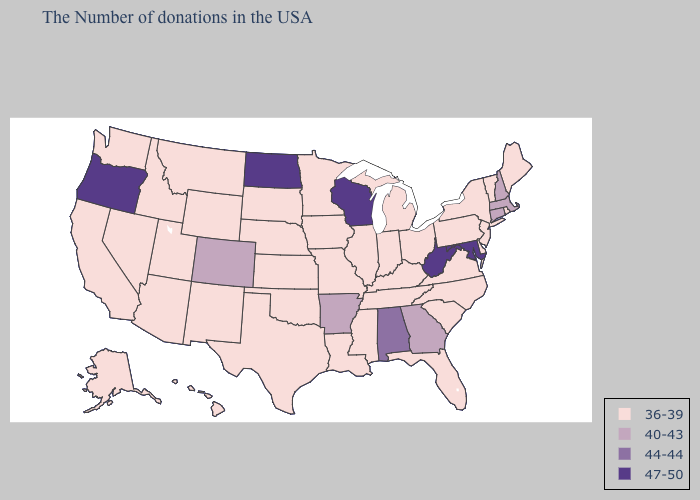Which states hav the highest value in the Northeast?
Write a very short answer. Massachusetts, New Hampshire, Connecticut. Does Kansas have the same value as Virginia?
Write a very short answer. Yes. Name the states that have a value in the range 47-50?
Quick response, please. Maryland, West Virginia, Wisconsin, North Dakota, Oregon. What is the value of New Jersey?
Short answer required. 36-39. Among the states that border Arkansas , which have the lowest value?
Be succinct. Tennessee, Mississippi, Louisiana, Missouri, Oklahoma, Texas. Does North Carolina have the highest value in the South?
Give a very brief answer. No. Name the states that have a value in the range 40-43?
Keep it brief. Massachusetts, New Hampshire, Connecticut, Georgia, Arkansas, Colorado. Does the first symbol in the legend represent the smallest category?
Be succinct. Yes. Name the states that have a value in the range 44-44?
Keep it brief. Alabama. Does Indiana have the lowest value in the USA?
Quick response, please. Yes. Does Indiana have the lowest value in the USA?
Short answer required. Yes. Name the states that have a value in the range 36-39?
Short answer required. Maine, Rhode Island, Vermont, New York, New Jersey, Delaware, Pennsylvania, Virginia, North Carolina, South Carolina, Ohio, Florida, Michigan, Kentucky, Indiana, Tennessee, Illinois, Mississippi, Louisiana, Missouri, Minnesota, Iowa, Kansas, Nebraska, Oklahoma, Texas, South Dakota, Wyoming, New Mexico, Utah, Montana, Arizona, Idaho, Nevada, California, Washington, Alaska, Hawaii. Which states hav the highest value in the South?
Give a very brief answer. Maryland, West Virginia. Does North Dakota have the highest value in the MidWest?
Keep it brief. Yes. Name the states that have a value in the range 44-44?
Short answer required. Alabama. 